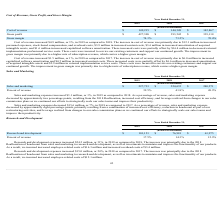According to Cornerstone Ondemand's financial document, Why did gross margin improve between 2018 and 2019? The improvement in gross margin was primarily due to a higher mix of subscription revenue, which carries a higher gross margin. The document states: "sting customers and support our continued growth. The improvement in gross margin was primarily due to a higher mix of subscription revenue, which car..." Also, What was the cost of revenue in 2019? According to the financial document, $149,215 (in thousands). The relevant text states: "Cost of revenue $ 149,215 $ 144,349 $ 142,867..." Also, What was the gross profit in 2019? According to the financial document, $427,308 (in thousands). The relevant text states: "Gross profit $ 427,308 $ 393,542 $ 339,118..." Also, can you calculate: What was the change in cost of revenue between 2017 and 2018? Based on the calculation: ($144,349-$142,867), the result is 1482 (in thousands). This is based on the information: "Cost of revenue $ 149,215 $ 144,349 $ 142,867 Cost of revenue $ 149,215 $ 144,349 $ 142,867..." The key data points involved are: 142,867, 144,349. Also, can you calculate: What was the percentage change in gross profit between 2018 and 2019? To answer this question, I need to perform calculations using the financial data. The calculation is: ($427,308-$393,542)/$393,542, which equals 8.58 (percentage). This is based on the information: "Gross profit $ 427,308 $ 393,542 $ 339,118 Gross profit $ 427,308 $ 393,542 $ 339,118..." The key data points involved are: 393,542, 427,308. Also, can you calculate: What was the change in gross margin between 2018 and 2019? Based on the calculation: (74.1%-73.2%), the result is 0.9 (percentage). This is based on the information: "Gross margin 74.1% 73.2% 70.4% Gross margin 74.1% 73.2% 70.4%..." The key data points involved are: 73.2, 74.1. 